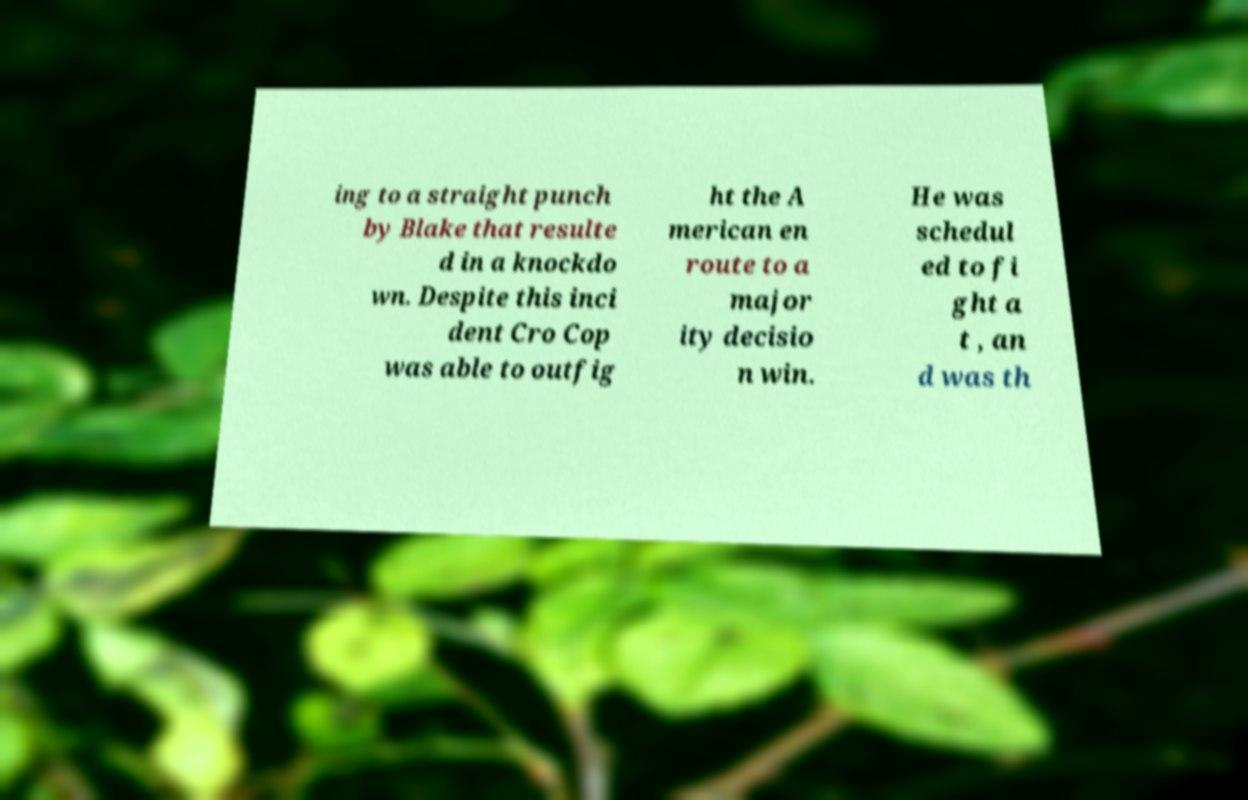What messages or text are displayed in this image? I need them in a readable, typed format. ing to a straight punch by Blake that resulte d in a knockdo wn. Despite this inci dent Cro Cop was able to outfig ht the A merican en route to a major ity decisio n win. He was schedul ed to fi ght a t , an d was th 